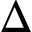<formula> <loc_0><loc_0><loc_500><loc_500>\Delta</formula> 